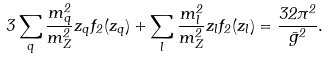Convert formula to latex. <formula><loc_0><loc_0><loc_500><loc_500>3 \sum _ { q } { \frac { m _ { q } ^ { 2 } } { m _ { Z } ^ { 2 } } } z _ { q } f _ { 2 } ( z _ { q } ) + \sum _ { l } { \frac { m _ { l } ^ { 2 } } { m _ { Z } ^ { 2 } } } z _ { l } f _ { 2 } ( z _ { l } ) = { \frac { 3 2 \pi ^ { 2 } } { \bar { g } ^ { 2 } } } .</formula> 